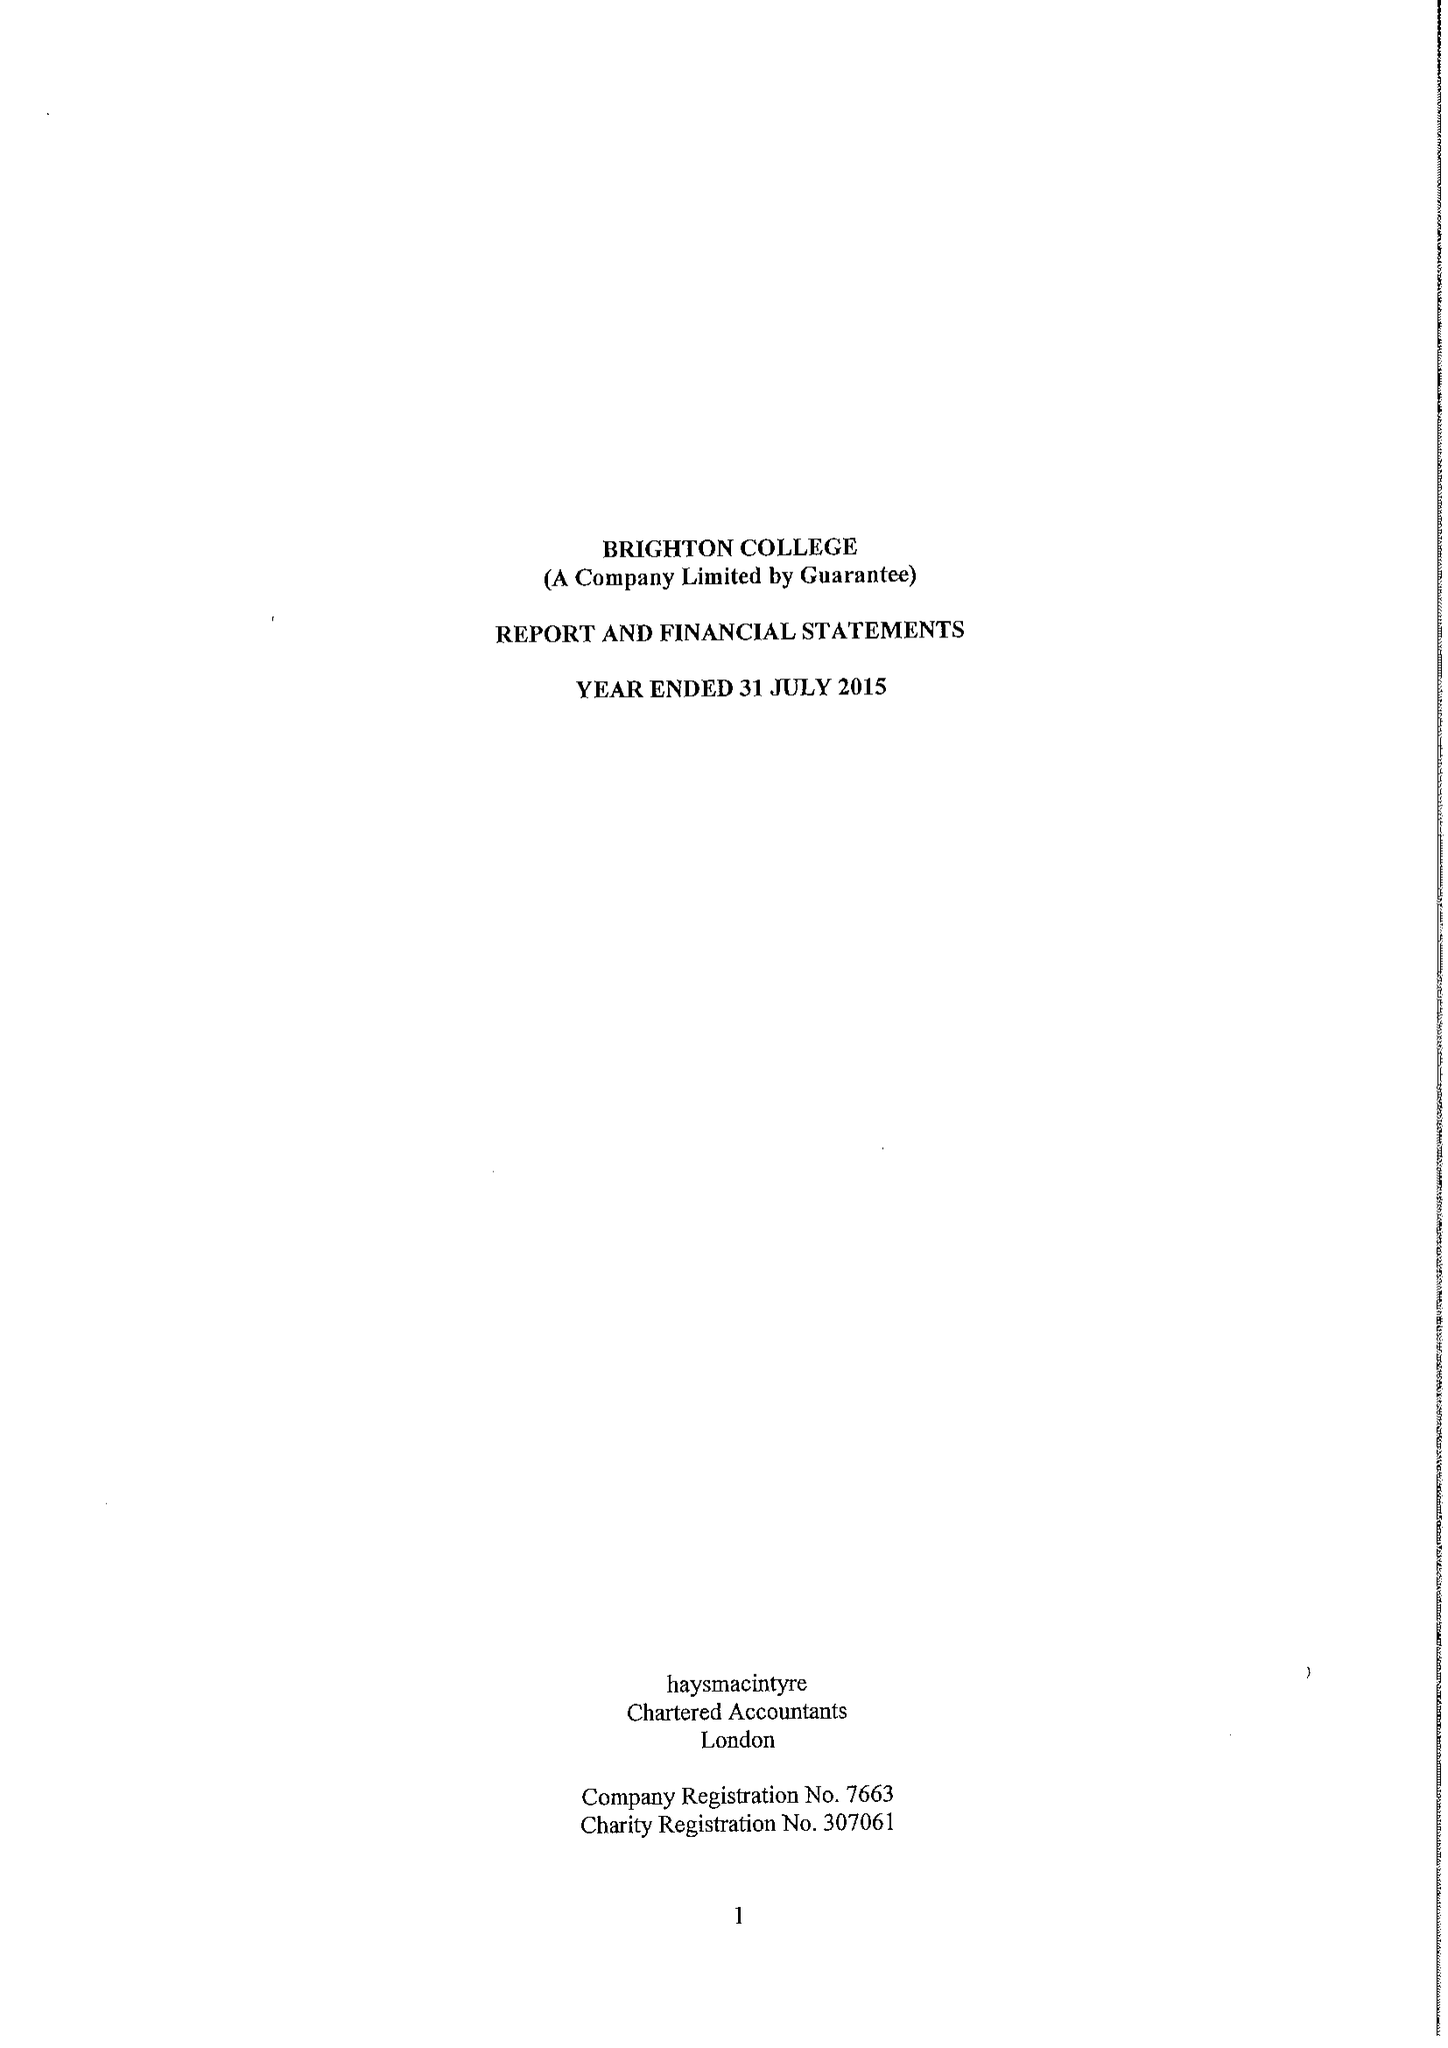What is the value for the address__post_town?
Answer the question using a single word or phrase. BRIGHTON 